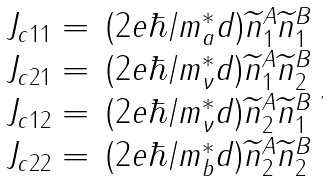Convert formula to latex. <formula><loc_0><loc_0><loc_500><loc_500>\begin{array} { l l } J _ { c 1 1 } = & ( 2 e \hbar { / } m _ { a } ^ { * } d ) \widetilde { n } _ { 1 } ^ { A } \widetilde { n } _ { 1 } ^ { B } \\ J _ { c 2 1 } = & ( 2 e \hbar { / } m _ { \nu } ^ { * } d ) \widetilde { n } _ { 1 } ^ { A } \widetilde { n } _ { 2 } ^ { B } \\ J _ { c 1 2 } = & ( 2 e \hbar { / } m _ { \nu } ^ { * } d ) \widetilde { n } _ { 2 } ^ { A } \widetilde { n } _ { 1 } ^ { B } \\ J _ { c 2 2 } = & ( 2 e \hbar { / } m _ { b } ^ { * } d ) \widetilde { n } _ { 2 } ^ { A } \widetilde { n } _ { 2 } ^ { B } \end{array} ,</formula> 